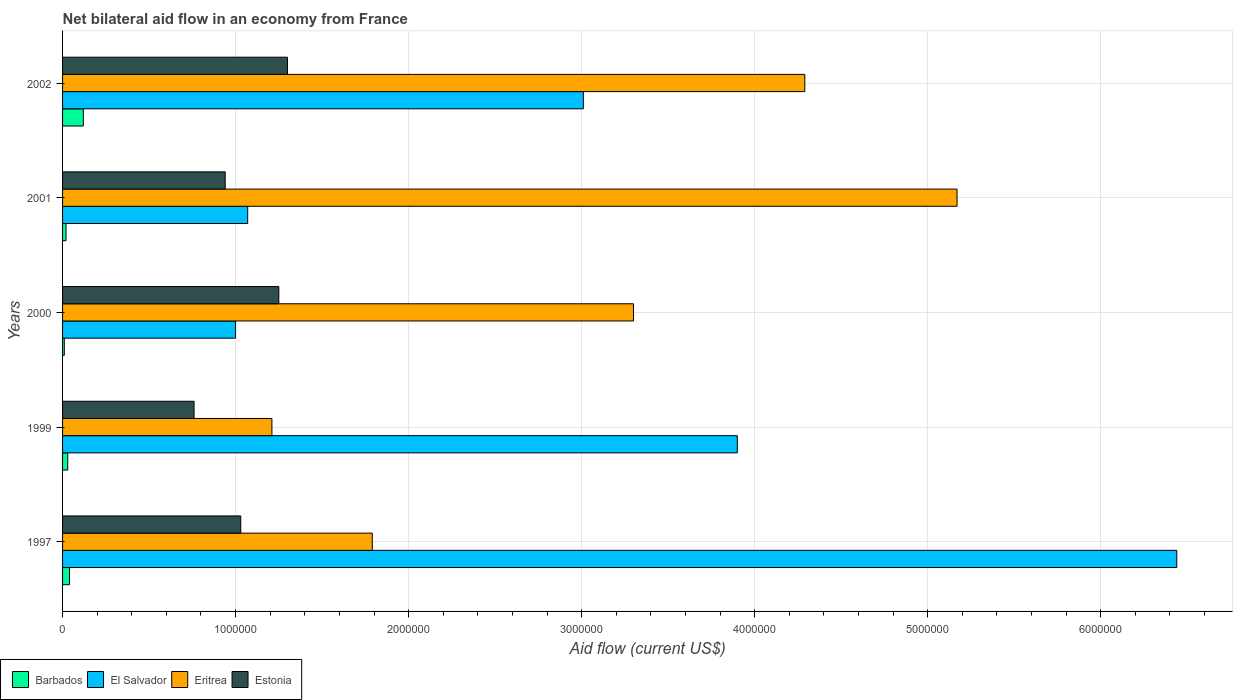How many groups of bars are there?
Ensure brevity in your answer.  5. Are the number of bars per tick equal to the number of legend labels?
Offer a terse response. Yes. Are the number of bars on each tick of the Y-axis equal?
Keep it short and to the point. Yes. How many bars are there on the 2nd tick from the top?
Keep it short and to the point. 4. How many bars are there on the 3rd tick from the bottom?
Your answer should be compact. 4. What is the label of the 4th group of bars from the top?
Offer a terse response. 1999. In how many cases, is the number of bars for a given year not equal to the number of legend labels?
Offer a terse response. 0. What is the net bilateral aid flow in Eritrea in 2000?
Offer a very short reply. 3.30e+06. Across all years, what is the maximum net bilateral aid flow in Barbados?
Provide a short and direct response. 1.20e+05. Across all years, what is the minimum net bilateral aid flow in Barbados?
Offer a very short reply. 10000. In which year was the net bilateral aid flow in Eritrea minimum?
Ensure brevity in your answer.  1999. What is the total net bilateral aid flow in Estonia in the graph?
Keep it short and to the point. 5.28e+06. What is the difference between the net bilateral aid flow in El Salvador in 1999 and that in 2002?
Make the answer very short. 8.90e+05. What is the difference between the net bilateral aid flow in El Salvador in 1997 and the net bilateral aid flow in Barbados in 2002?
Make the answer very short. 6.32e+06. What is the average net bilateral aid flow in Estonia per year?
Your answer should be very brief. 1.06e+06. In the year 2002, what is the difference between the net bilateral aid flow in Barbados and net bilateral aid flow in Eritrea?
Provide a short and direct response. -4.17e+06. In how many years, is the net bilateral aid flow in Eritrea greater than 1200000 US$?
Give a very brief answer. 5. What is the ratio of the net bilateral aid flow in El Salvador in 2000 to that in 2002?
Give a very brief answer. 0.33. Is the net bilateral aid flow in El Salvador in 1999 less than that in 2001?
Offer a terse response. No. What is the difference between the highest and the lowest net bilateral aid flow in El Salvador?
Ensure brevity in your answer.  5.44e+06. Is it the case that in every year, the sum of the net bilateral aid flow in Estonia and net bilateral aid flow in Eritrea is greater than the sum of net bilateral aid flow in El Salvador and net bilateral aid flow in Barbados?
Offer a terse response. No. What does the 4th bar from the top in 1999 represents?
Provide a succinct answer. Barbados. What does the 2nd bar from the bottom in 2002 represents?
Provide a succinct answer. El Salvador. Is it the case that in every year, the sum of the net bilateral aid flow in Estonia and net bilateral aid flow in Barbados is greater than the net bilateral aid flow in El Salvador?
Your answer should be very brief. No. What is the difference between two consecutive major ticks on the X-axis?
Your response must be concise. 1.00e+06. Where does the legend appear in the graph?
Offer a very short reply. Bottom left. What is the title of the graph?
Your answer should be very brief. Net bilateral aid flow in an economy from France. What is the label or title of the X-axis?
Keep it short and to the point. Aid flow (current US$). What is the label or title of the Y-axis?
Provide a succinct answer. Years. What is the Aid flow (current US$) in Barbados in 1997?
Keep it short and to the point. 4.00e+04. What is the Aid flow (current US$) of El Salvador in 1997?
Provide a succinct answer. 6.44e+06. What is the Aid flow (current US$) of Eritrea in 1997?
Offer a terse response. 1.79e+06. What is the Aid flow (current US$) in Estonia in 1997?
Your answer should be compact. 1.03e+06. What is the Aid flow (current US$) in Barbados in 1999?
Offer a terse response. 3.00e+04. What is the Aid flow (current US$) in El Salvador in 1999?
Provide a short and direct response. 3.90e+06. What is the Aid flow (current US$) in Eritrea in 1999?
Your response must be concise. 1.21e+06. What is the Aid flow (current US$) of Estonia in 1999?
Your answer should be compact. 7.60e+05. What is the Aid flow (current US$) in El Salvador in 2000?
Offer a terse response. 1.00e+06. What is the Aid flow (current US$) in Eritrea in 2000?
Your response must be concise. 3.30e+06. What is the Aid flow (current US$) of Estonia in 2000?
Your answer should be compact. 1.25e+06. What is the Aid flow (current US$) in El Salvador in 2001?
Your response must be concise. 1.07e+06. What is the Aid flow (current US$) in Eritrea in 2001?
Give a very brief answer. 5.17e+06. What is the Aid flow (current US$) of Estonia in 2001?
Offer a very short reply. 9.40e+05. What is the Aid flow (current US$) in El Salvador in 2002?
Offer a very short reply. 3.01e+06. What is the Aid flow (current US$) of Eritrea in 2002?
Make the answer very short. 4.29e+06. What is the Aid flow (current US$) of Estonia in 2002?
Give a very brief answer. 1.30e+06. Across all years, what is the maximum Aid flow (current US$) of Barbados?
Your response must be concise. 1.20e+05. Across all years, what is the maximum Aid flow (current US$) of El Salvador?
Your answer should be very brief. 6.44e+06. Across all years, what is the maximum Aid flow (current US$) of Eritrea?
Keep it short and to the point. 5.17e+06. Across all years, what is the maximum Aid flow (current US$) of Estonia?
Offer a terse response. 1.30e+06. Across all years, what is the minimum Aid flow (current US$) in Barbados?
Provide a short and direct response. 10000. Across all years, what is the minimum Aid flow (current US$) in El Salvador?
Ensure brevity in your answer.  1.00e+06. Across all years, what is the minimum Aid flow (current US$) in Eritrea?
Make the answer very short. 1.21e+06. Across all years, what is the minimum Aid flow (current US$) in Estonia?
Offer a very short reply. 7.60e+05. What is the total Aid flow (current US$) of Barbados in the graph?
Make the answer very short. 2.20e+05. What is the total Aid flow (current US$) of El Salvador in the graph?
Your answer should be very brief. 1.54e+07. What is the total Aid flow (current US$) in Eritrea in the graph?
Your answer should be very brief. 1.58e+07. What is the total Aid flow (current US$) in Estonia in the graph?
Keep it short and to the point. 5.28e+06. What is the difference between the Aid flow (current US$) in El Salvador in 1997 and that in 1999?
Your answer should be compact. 2.54e+06. What is the difference between the Aid flow (current US$) in Eritrea in 1997 and that in 1999?
Make the answer very short. 5.80e+05. What is the difference between the Aid flow (current US$) in Estonia in 1997 and that in 1999?
Your answer should be compact. 2.70e+05. What is the difference between the Aid flow (current US$) of Barbados in 1997 and that in 2000?
Offer a terse response. 3.00e+04. What is the difference between the Aid flow (current US$) in El Salvador in 1997 and that in 2000?
Keep it short and to the point. 5.44e+06. What is the difference between the Aid flow (current US$) of Eritrea in 1997 and that in 2000?
Make the answer very short. -1.51e+06. What is the difference between the Aid flow (current US$) in Estonia in 1997 and that in 2000?
Offer a terse response. -2.20e+05. What is the difference between the Aid flow (current US$) in El Salvador in 1997 and that in 2001?
Ensure brevity in your answer.  5.37e+06. What is the difference between the Aid flow (current US$) of Eritrea in 1997 and that in 2001?
Give a very brief answer. -3.38e+06. What is the difference between the Aid flow (current US$) in Estonia in 1997 and that in 2001?
Offer a very short reply. 9.00e+04. What is the difference between the Aid flow (current US$) in Barbados in 1997 and that in 2002?
Keep it short and to the point. -8.00e+04. What is the difference between the Aid flow (current US$) in El Salvador in 1997 and that in 2002?
Provide a short and direct response. 3.43e+06. What is the difference between the Aid flow (current US$) of Eritrea in 1997 and that in 2002?
Give a very brief answer. -2.50e+06. What is the difference between the Aid flow (current US$) in El Salvador in 1999 and that in 2000?
Offer a terse response. 2.90e+06. What is the difference between the Aid flow (current US$) of Eritrea in 1999 and that in 2000?
Offer a terse response. -2.09e+06. What is the difference between the Aid flow (current US$) of Estonia in 1999 and that in 2000?
Keep it short and to the point. -4.90e+05. What is the difference between the Aid flow (current US$) in El Salvador in 1999 and that in 2001?
Offer a terse response. 2.83e+06. What is the difference between the Aid flow (current US$) of Eritrea in 1999 and that in 2001?
Give a very brief answer. -3.96e+06. What is the difference between the Aid flow (current US$) of Estonia in 1999 and that in 2001?
Your answer should be compact. -1.80e+05. What is the difference between the Aid flow (current US$) in El Salvador in 1999 and that in 2002?
Your answer should be compact. 8.90e+05. What is the difference between the Aid flow (current US$) of Eritrea in 1999 and that in 2002?
Offer a terse response. -3.08e+06. What is the difference between the Aid flow (current US$) of Estonia in 1999 and that in 2002?
Make the answer very short. -5.40e+05. What is the difference between the Aid flow (current US$) of El Salvador in 2000 and that in 2001?
Keep it short and to the point. -7.00e+04. What is the difference between the Aid flow (current US$) of Eritrea in 2000 and that in 2001?
Provide a short and direct response. -1.87e+06. What is the difference between the Aid flow (current US$) of Estonia in 2000 and that in 2001?
Offer a terse response. 3.10e+05. What is the difference between the Aid flow (current US$) in Barbados in 2000 and that in 2002?
Provide a succinct answer. -1.10e+05. What is the difference between the Aid flow (current US$) in El Salvador in 2000 and that in 2002?
Provide a succinct answer. -2.01e+06. What is the difference between the Aid flow (current US$) of Eritrea in 2000 and that in 2002?
Provide a short and direct response. -9.90e+05. What is the difference between the Aid flow (current US$) in El Salvador in 2001 and that in 2002?
Offer a very short reply. -1.94e+06. What is the difference between the Aid flow (current US$) in Eritrea in 2001 and that in 2002?
Give a very brief answer. 8.80e+05. What is the difference between the Aid flow (current US$) of Estonia in 2001 and that in 2002?
Your answer should be compact. -3.60e+05. What is the difference between the Aid flow (current US$) of Barbados in 1997 and the Aid flow (current US$) of El Salvador in 1999?
Your answer should be compact. -3.86e+06. What is the difference between the Aid flow (current US$) in Barbados in 1997 and the Aid flow (current US$) in Eritrea in 1999?
Your answer should be compact. -1.17e+06. What is the difference between the Aid flow (current US$) in Barbados in 1997 and the Aid flow (current US$) in Estonia in 1999?
Offer a terse response. -7.20e+05. What is the difference between the Aid flow (current US$) in El Salvador in 1997 and the Aid flow (current US$) in Eritrea in 1999?
Provide a succinct answer. 5.23e+06. What is the difference between the Aid flow (current US$) in El Salvador in 1997 and the Aid flow (current US$) in Estonia in 1999?
Offer a terse response. 5.68e+06. What is the difference between the Aid flow (current US$) of Eritrea in 1997 and the Aid flow (current US$) of Estonia in 1999?
Provide a short and direct response. 1.03e+06. What is the difference between the Aid flow (current US$) of Barbados in 1997 and the Aid flow (current US$) of El Salvador in 2000?
Ensure brevity in your answer.  -9.60e+05. What is the difference between the Aid flow (current US$) in Barbados in 1997 and the Aid flow (current US$) in Eritrea in 2000?
Make the answer very short. -3.26e+06. What is the difference between the Aid flow (current US$) in Barbados in 1997 and the Aid flow (current US$) in Estonia in 2000?
Provide a succinct answer. -1.21e+06. What is the difference between the Aid flow (current US$) of El Salvador in 1997 and the Aid flow (current US$) of Eritrea in 2000?
Offer a terse response. 3.14e+06. What is the difference between the Aid flow (current US$) in El Salvador in 1997 and the Aid flow (current US$) in Estonia in 2000?
Give a very brief answer. 5.19e+06. What is the difference between the Aid flow (current US$) of Eritrea in 1997 and the Aid flow (current US$) of Estonia in 2000?
Your response must be concise. 5.40e+05. What is the difference between the Aid flow (current US$) of Barbados in 1997 and the Aid flow (current US$) of El Salvador in 2001?
Give a very brief answer. -1.03e+06. What is the difference between the Aid flow (current US$) of Barbados in 1997 and the Aid flow (current US$) of Eritrea in 2001?
Offer a terse response. -5.13e+06. What is the difference between the Aid flow (current US$) in Barbados in 1997 and the Aid flow (current US$) in Estonia in 2001?
Keep it short and to the point. -9.00e+05. What is the difference between the Aid flow (current US$) of El Salvador in 1997 and the Aid flow (current US$) of Eritrea in 2001?
Keep it short and to the point. 1.27e+06. What is the difference between the Aid flow (current US$) of El Salvador in 1997 and the Aid flow (current US$) of Estonia in 2001?
Your response must be concise. 5.50e+06. What is the difference between the Aid flow (current US$) of Eritrea in 1997 and the Aid flow (current US$) of Estonia in 2001?
Keep it short and to the point. 8.50e+05. What is the difference between the Aid flow (current US$) in Barbados in 1997 and the Aid flow (current US$) in El Salvador in 2002?
Your answer should be very brief. -2.97e+06. What is the difference between the Aid flow (current US$) in Barbados in 1997 and the Aid flow (current US$) in Eritrea in 2002?
Offer a very short reply. -4.25e+06. What is the difference between the Aid flow (current US$) in Barbados in 1997 and the Aid flow (current US$) in Estonia in 2002?
Your answer should be very brief. -1.26e+06. What is the difference between the Aid flow (current US$) in El Salvador in 1997 and the Aid flow (current US$) in Eritrea in 2002?
Offer a terse response. 2.15e+06. What is the difference between the Aid flow (current US$) of El Salvador in 1997 and the Aid flow (current US$) of Estonia in 2002?
Your answer should be very brief. 5.14e+06. What is the difference between the Aid flow (current US$) of Eritrea in 1997 and the Aid flow (current US$) of Estonia in 2002?
Your answer should be compact. 4.90e+05. What is the difference between the Aid flow (current US$) of Barbados in 1999 and the Aid flow (current US$) of El Salvador in 2000?
Keep it short and to the point. -9.70e+05. What is the difference between the Aid flow (current US$) of Barbados in 1999 and the Aid flow (current US$) of Eritrea in 2000?
Provide a short and direct response. -3.27e+06. What is the difference between the Aid flow (current US$) of Barbados in 1999 and the Aid flow (current US$) of Estonia in 2000?
Ensure brevity in your answer.  -1.22e+06. What is the difference between the Aid flow (current US$) of El Salvador in 1999 and the Aid flow (current US$) of Eritrea in 2000?
Make the answer very short. 6.00e+05. What is the difference between the Aid flow (current US$) in El Salvador in 1999 and the Aid flow (current US$) in Estonia in 2000?
Your answer should be very brief. 2.65e+06. What is the difference between the Aid flow (current US$) of Eritrea in 1999 and the Aid flow (current US$) of Estonia in 2000?
Offer a very short reply. -4.00e+04. What is the difference between the Aid flow (current US$) of Barbados in 1999 and the Aid flow (current US$) of El Salvador in 2001?
Your response must be concise. -1.04e+06. What is the difference between the Aid flow (current US$) in Barbados in 1999 and the Aid flow (current US$) in Eritrea in 2001?
Make the answer very short. -5.14e+06. What is the difference between the Aid flow (current US$) of Barbados in 1999 and the Aid flow (current US$) of Estonia in 2001?
Offer a terse response. -9.10e+05. What is the difference between the Aid flow (current US$) of El Salvador in 1999 and the Aid flow (current US$) of Eritrea in 2001?
Offer a very short reply. -1.27e+06. What is the difference between the Aid flow (current US$) of El Salvador in 1999 and the Aid flow (current US$) of Estonia in 2001?
Give a very brief answer. 2.96e+06. What is the difference between the Aid flow (current US$) in Eritrea in 1999 and the Aid flow (current US$) in Estonia in 2001?
Your answer should be compact. 2.70e+05. What is the difference between the Aid flow (current US$) in Barbados in 1999 and the Aid flow (current US$) in El Salvador in 2002?
Provide a succinct answer. -2.98e+06. What is the difference between the Aid flow (current US$) in Barbados in 1999 and the Aid flow (current US$) in Eritrea in 2002?
Give a very brief answer. -4.26e+06. What is the difference between the Aid flow (current US$) in Barbados in 1999 and the Aid flow (current US$) in Estonia in 2002?
Provide a short and direct response. -1.27e+06. What is the difference between the Aid flow (current US$) of El Salvador in 1999 and the Aid flow (current US$) of Eritrea in 2002?
Your response must be concise. -3.90e+05. What is the difference between the Aid flow (current US$) of El Salvador in 1999 and the Aid flow (current US$) of Estonia in 2002?
Your answer should be very brief. 2.60e+06. What is the difference between the Aid flow (current US$) of Barbados in 2000 and the Aid flow (current US$) of El Salvador in 2001?
Your response must be concise. -1.06e+06. What is the difference between the Aid flow (current US$) of Barbados in 2000 and the Aid flow (current US$) of Eritrea in 2001?
Provide a short and direct response. -5.16e+06. What is the difference between the Aid flow (current US$) of Barbados in 2000 and the Aid flow (current US$) of Estonia in 2001?
Offer a terse response. -9.30e+05. What is the difference between the Aid flow (current US$) in El Salvador in 2000 and the Aid flow (current US$) in Eritrea in 2001?
Your response must be concise. -4.17e+06. What is the difference between the Aid flow (current US$) of El Salvador in 2000 and the Aid flow (current US$) of Estonia in 2001?
Give a very brief answer. 6.00e+04. What is the difference between the Aid flow (current US$) of Eritrea in 2000 and the Aid flow (current US$) of Estonia in 2001?
Offer a terse response. 2.36e+06. What is the difference between the Aid flow (current US$) of Barbados in 2000 and the Aid flow (current US$) of Eritrea in 2002?
Offer a very short reply. -4.28e+06. What is the difference between the Aid flow (current US$) in Barbados in 2000 and the Aid flow (current US$) in Estonia in 2002?
Make the answer very short. -1.29e+06. What is the difference between the Aid flow (current US$) in El Salvador in 2000 and the Aid flow (current US$) in Eritrea in 2002?
Keep it short and to the point. -3.29e+06. What is the difference between the Aid flow (current US$) of Eritrea in 2000 and the Aid flow (current US$) of Estonia in 2002?
Provide a succinct answer. 2.00e+06. What is the difference between the Aid flow (current US$) of Barbados in 2001 and the Aid flow (current US$) of El Salvador in 2002?
Offer a terse response. -2.99e+06. What is the difference between the Aid flow (current US$) in Barbados in 2001 and the Aid flow (current US$) in Eritrea in 2002?
Your answer should be very brief. -4.27e+06. What is the difference between the Aid flow (current US$) of Barbados in 2001 and the Aid flow (current US$) of Estonia in 2002?
Your response must be concise. -1.28e+06. What is the difference between the Aid flow (current US$) of El Salvador in 2001 and the Aid flow (current US$) of Eritrea in 2002?
Give a very brief answer. -3.22e+06. What is the difference between the Aid flow (current US$) in El Salvador in 2001 and the Aid flow (current US$) in Estonia in 2002?
Keep it short and to the point. -2.30e+05. What is the difference between the Aid flow (current US$) in Eritrea in 2001 and the Aid flow (current US$) in Estonia in 2002?
Provide a short and direct response. 3.87e+06. What is the average Aid flow (current US$) of Barbados per year?
Offer a terse response. 4.40e+04. What is the average Aid flow (current US$) in El Salvador per year?
Give a very brief answer. 3.08e+06. What is the average Aid flow (current US$) in Eritrea per year?
Offer a terse response. 3.15e+06. What is the average Aid flow (current US$) of Estonia per year?
Keep it short and to the point. 1.06e+06. In the year 1997, what is the difference between the Aid flow (current US$) in Barbados and Aid flow (current US$) in El Salvador?
Keep it short and to the point. -6.40e+06. In the year 1997, what is the difference between the Aid flow (current US$) of Barbados and Aid flow (current US$) of Eritrea?
Ensure brevity in your answer.  -1.75e+06. In the year 1997, what is the difference between the Aid flow (current US$) in Barbados and Aid flow (current US$) in Estonia?
Keep it short and to the point. -9.90e+05. In the year 1997, what is the difference between the Aid flow (current US$) of El Salvador and Aid flow (current US$) of Eritrea?
Provide a short and direct response. 4.65e+06. In the year 1997, what is the difference between the Aid flow (current US$) of El Salvador and Aid flow (current US$) of Estonia?
Provide a succinct answer. 5.41e+06. In the year 1997, what is the difference between the Aid flow (current US$) in Eritrea and Aid flow (current US$) in Estonia?
Offer a very short reply. 7.60e+05. In the year 1999, what is the difference between the Aid flow (current US$) of Barbados and Aid flow (current US$) of El Salvador?
Offer a very short reply. -3.87e+06. In the year 1999, what is the difference between the Aid flow (current US$) in Barbados and Aid flow (current US$) in Eritrea?
Provide a succinct answer. -1.18e+06. In the year 1999, what is the difference between the Aid flow (current US$) in Barbados and Aid flow (current US$) in Estonia?
Ensure brevity in your answer.  -7.30e+05. In the year 1999, what is the difference between the Aid flow (current US$) in El Salvador and Aid flow (current US$) in Eritrea?
Offer a very short reply. 2.69e+06. In the year 1999, what is the difference between the Aid flow (current US$) in El Salvador and Aid flow (current US$) in Estonia?
Offer a very short reply. 3.14e+06. In the year 1999, what is the difference between the Aid flow (current US$) of Eritrea and Aid flow (current US$) of Estonia?
Make the answer very short. 4.50e+05. In the year 2000, what is the difference between the Aid flow (current US$) in Barbados and Aid flow (current US$) in El Salvador?
Keep it short and to the point. -9.90e+05. In the year 2000, what is the difference between the Aid flow (current US$) in Barbados and Aid flow (current US$) in Eritrea?
Keep it short and to the point. -3.29e+06. In the year 2000, what is the difference between the Aid flow (current US$) of Barbados and Aid flow (current US$) of Estonia?
Your response must be concise. -1.24e+06. In the year 2000, what is the difference between the Aid flow (current US$) of El Salvador and Aid flow (current US$) of Eritrea?
Provide a short and direct response. -2.30e+06. In the year 2000, what is the difference between the Aid flow (current US$) in El Salvador and Aid flow (current US$) in Estonia?
Provide a succinct answer. -2.50e+05. In the year 2000, what is the difference between the Aid flow (current US$) of Eritrea and Aid flow (current US$) of Estonia?
Ensure brevity in your answer.  2.05e+06. In the year 2001, what is the difference between the Aid flow (current US$) in Barbados and Aid flow (current US$) in El Salvador?
Provide a succinct answer. -1.05e+06. In the year 2001, what is the difference between the Aid flow (current US$) in Barbados and Aid flow (current US$) in Eritrea?
Your answer should be compact. -5.15e+06. In the year 2001, what is the difference between the Aid flow (current US$) in Barbados and Aid flow (current US$) in Estonia?
Offer a very short reply. -9.20e+05. In the year 2001, what is the difference between the Aid flow (current US$) of El Salvador and Aid flow (current US$) of Eritrea?
Your answer should be compact. -4.10e+06. In the year 2001, what is the difference between the Aid flow (current US$) of Eritrea and Aid flow (current US$) of Estonia?
Offer a terse response. 4.23e+06. In the year 2002, what is the difference between the Aid flow (current US$) of Barbados and Aid flow (current US$) of El Salvador?
Offer a very short reply. -2.89e+06. In the year 2002, what is the difference between the Aid flow (current US$) of Barbados and Aid flow (current US$) of Eritrea?
Offer a terse response. -4.17e+06. In the year 2002, what is the difference between the Aid flow (current US$) in Barbados and Aid flow (current US$) in Estonia?
Give a very brief answer. -1.18e+06. In the year 2002, what is the difference between the Aid flow (current US$) of El Salvador and Aid flow (current US$) of Eritrea?
Your response must be concise. -1.28e+06. In the year 2002, what is the difference between the Aid flow (current US$) in El Salvador and Aid flow (current US$) in Estonia?
Your response must be concise. 1.71e+06. In the year 2002, what is the difference between the Aid flow (current US$) of Eritrea and Aid flow (current US$) of Estonia?
Offer a terse response. 2.99e+06. What is the ratio of the Aid flow (current US$) of Barbados in 1997 to that in 1999?
Ensure brevity in your answer.  1.33. What is the ratio of the Aid flow (current US$) of El Salvador in 1997 to that in 1999?
Keep it short and to the point. 1.65. What is the ratio of the Aid flow (current US$) in Eritrea in 1997 to that in 1999?
Your answer should be compact. 1.48. What is the ratio of the Aid flow (current US$) in Estonia in 1997 to that in 1999?
Offer a very short reply. 1.36. What is the ratio of the Aid flow (current US$) in El Salvador in 1997 to that in 2000?
Offer a terse response. 6.44. What is the ratio of the Aid flow (current US$) in Eritrea in 1997 to that in 2000?
Offer a very short reply. 0.54. What is the ratio of the Aid flow (current US$) of Estonia in 1997 to that in 2000?
Your answer should be very brief. 0.82. What is the ratio of the Aid flow (current US$) of El Salvador in 1997 to that in 2001?
Your response must be concise. 6.02. What is the ratio of the Aid flow (current US$) of Eritrea in 1997 to that in 2001?
Your answer should be very brief. 0.35. What is the ratio of the Aid flow (current US$) in Estonia in 1997 to that in 2001?
Keep it short and to the point. 1.1. What is the ratio of the Aid flow (current US$) in El Salvador in 1997 to that in 2002?
Offer a very short reply. 2.14. What is the ratio of the Aid flow (current US$) in Eritrea in 1997 to that in 2002?
Offer a very short reply. 0.42. What is the ratio of the Aid flow (current US$) in Estonia in 1997 to that in 2002?
Offer a very short reply. 0.79. What is the ratio of the Aid flow (current US$) in El Salvador in 1999 to that in 2000?
Ensure brevity in your answer.  3.9. What is the ratio of the Aid flow (current US$) in Eritrea in 1999 to that in 2000?
Offer a very short reply. 0.37. What is the ratio of the Aid flow (current US$) in Estonia in 1999 to that in 2000?
Your answer should be compact. 0.61. What is the ratio of the Aid flow (current US$) in Barbados in 1999 to that in 2001?
Ensure brevity in your answer.  1.5. What is the ratio of the Aid flow (current US$) in El Salvador in 1999 to that in 2001?
Ensure brevity in your answer.  3.64. What is the ratio of the Aid flow (current US$) in Eritrea in 1999 to that in 2001?
Provide a short and direct response. 0.23. What is the ratio of the Aid flow (current US$) of Estonia in 1999 to that in 2001?
Provide a succinct answer. 0.81. What is the ratio of the Aid flow (current US$) of Barbados in 1999 to that in 2002?
Ensure brevity in your answer.  0.25. What is the ratio of the Aid flow (current US$) of El Salvador in 1999 to that in 2002?
Ensure brevity in your answer.  1.3. What is the ratio of the Aid flow (current US$) in Eritrea in 1999 to that in 2002?
Provide a short and direct response. 0.28. What is the ratio of the Aid flow (current US$) in Estonia in 1999 to that in 2002?
Ensure brevity in your answer.  0.58. What is the ratio of the Aid flow (current US$) of El Salvador in 2000 to that in 2001?
Give a very brief answer. 0.93. What is the ratio of the Aid flow (current US$) in Eritrea in 2000 to that in 2001?
Offer a terse response. 0.64. What is the ratio of the Aid flow (current US$) of Estonia in 2000 to that in 2001?
Your answer should be very brief. 1.33. What is the ratio of the Aid flow (current US$) of Barbados in 2000 to that in 2002?
Your answer should be very brief. 0.08. What is the ratio of the Aid flow (current US$) of El Salvador in 2000 to that in 2002?
Your response must be concise. 0.33. What is the ratio of the Aid flow (current US$) of Eritrea in 2000 to that in 2002?
Give a very brief answer. 0.77. What is the ratio of the Aid flow (current US$) in Estonia in 2000 to that in 2002?
Your answer should be very brief. 0.96. What is the ratio of the Aid flow (current US$) of El Salvador in 2001 to that in 2002?
Provide a short and direct response. 0.36. What is the ratio of the Aid flow (current US$) of Eritrea in 2001 to that in 2002?
Make the answer very short. 1.21. What is the ratio of the Aid flow (current US$) in Estonia in 2001 to that in 2002?
Your answer should be compact. 0.72. What is the difference between the highest and the second highest Aid flow (current US$) in Barbados?
Your response must be concise. 8.00e+04. What is the difference between the highest and the second highest Aid flow (current US$) in El Salvador?
Your answer should be very brief. 2.54e+06. What is the difference between the highest and the second highest Aid flow (current US$) in Eritrea?
Offer a terse response. 8.80e+05. What is the difference between the highest and the second highest Aid flow (current US$) of Estonia?
Ensure brevity in your answer.  5.00e+04. What is the difference between the highest and the lowest Aid flow (current US$) of Barbados?
Your response must be concise. 1.10e+05. What is the difference between the highest and the lowest Aid flow (current US$) in El Salvador?
Your response must be concise. 5.44e+06. What is the difference between the highest and the lowest Aid flow (current US$) of Eritrea?
Your answer should be compact. 3.96e+06. What is the difference between the highest and the lowest Aid flow (current US$) in Estonia?
Keep it short and to the point. 5.40e+05. 